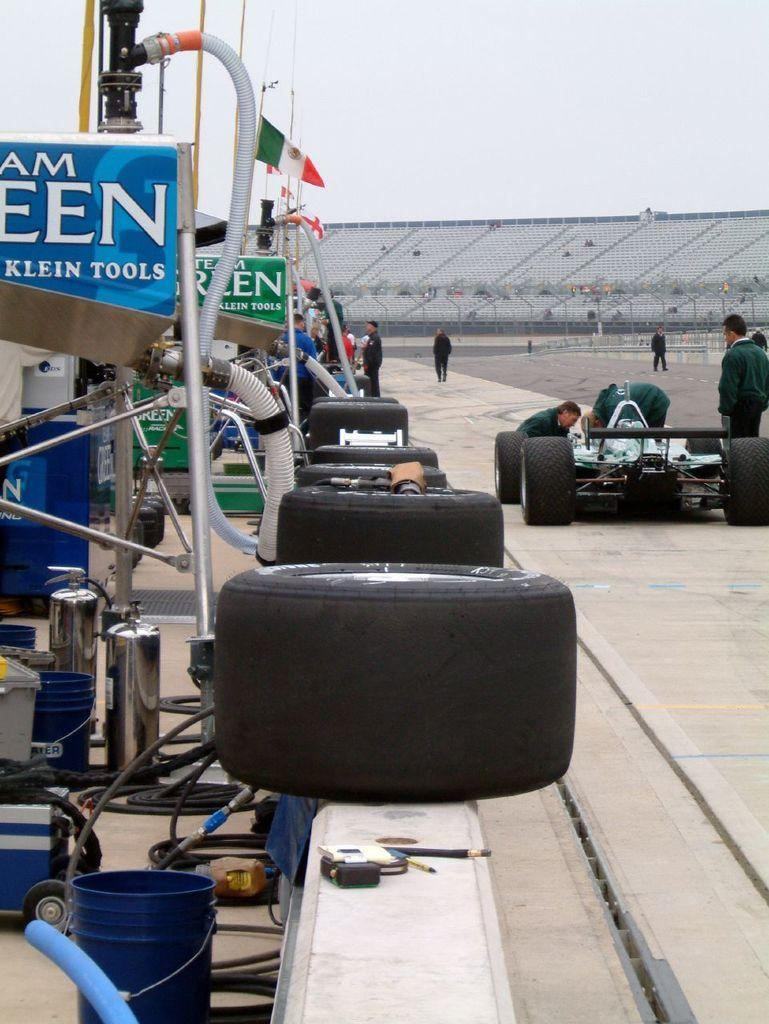What is the main subject of the image? The main subject of the image is a vehicle on the road. Are there any people in the image? Yes, there are people near the vehicle. What part of the vehicle can be seen in the image? There are tires visible in the image. What else can be seen in the image besides the vehicle and people? There are machines and wires in the image. What type of record can be seen spinning on the vehicle's dashboard in the image? There is no record present in the image; it only features a vehicle, people, tires, machines, and wires. Is there a scarf draped over the vehicle's hood in the image? There is no scarf visible in the image. 